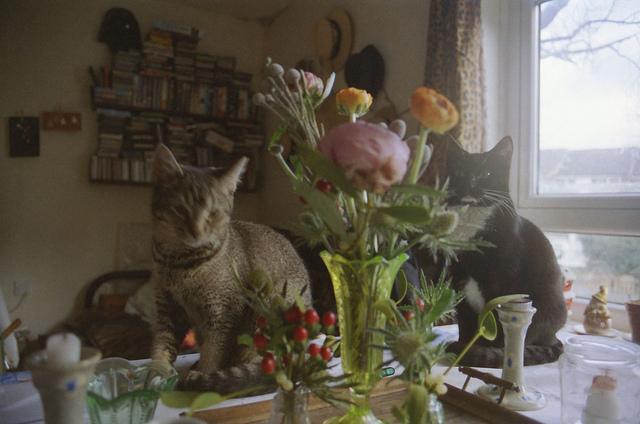How many cats are there?
Give a very brief answer. 2. How many paws can be seen on the cat?
Give a very brief answer. 2. How many animals are on the counter?
Give a very brief answer. 2. How many dining tables can you see?
Give a very brief answer. 2. How many horses are there?
Give a very brief answer. 0. 